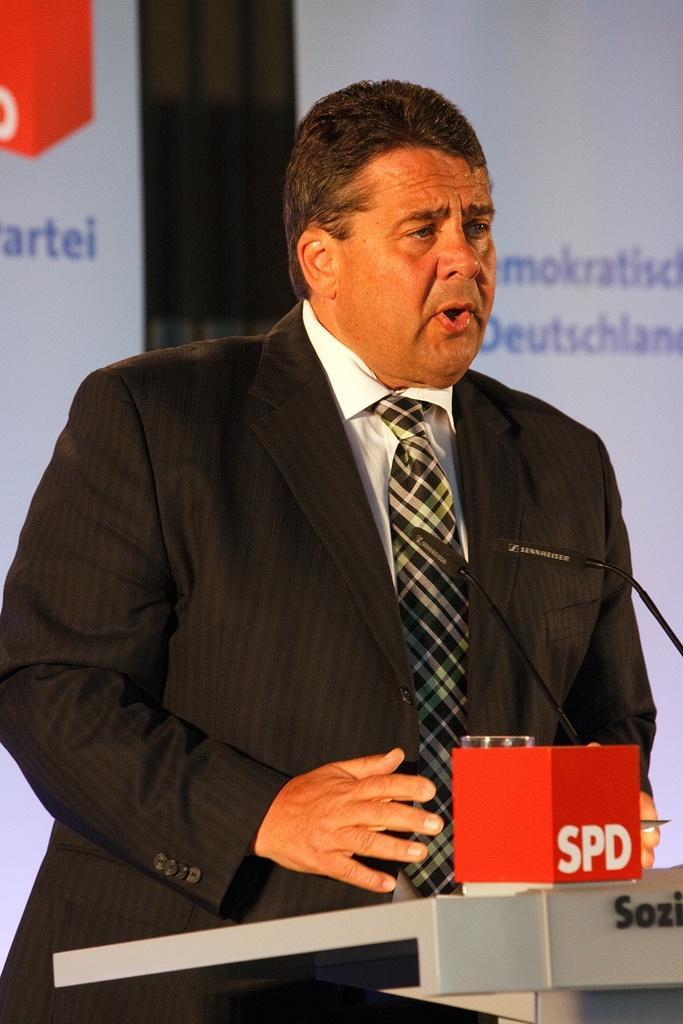Could you give a brief overview of what you see in this image? In this image we can see one man in a suit standing near the podium, holding an object and talking. There is one podium with text, two microphones attached to the podium and two objects on the podium. There is one black object and two white banners with text in the background. 